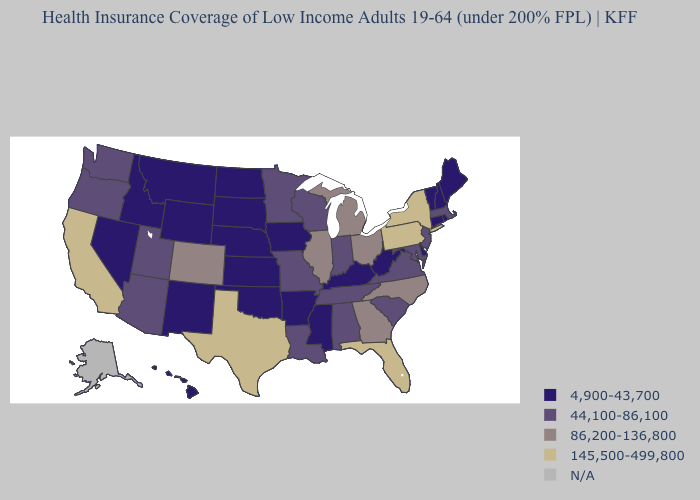What is the value of Minnesota?
Answer briefly. 44,100-86,100. Does Kansas have the highest value in the MidWest?
Keep it brief. No. Name the states that have a value in the range 86,200-136,800?
Answer briefly. Colorado, Georgia, Illinois, Michigan, North Carolina, Ohio. Is the legend a continuous bar?
Be succinct. No. What is the lowest value in the South?
Quick response, please. 4,900-43,700. How many symbols are there in the legend?
Short answer required. 5. Name the states that have a value in the range 86,200-136,800?
Write a very short answer. Colorado, Georgia, Illinois, Michigan, North Carolina, Ohio. Name the states that have a value in the range 4,900-43,700?
Concise answer only. Arkansas, Connecticut, Delaware, Hawaii, Idaho, Iowa, Kansas, Kentucky, Maine, Mississippi, Montana, Nebraska, Nevada, New Hampshire, New Mexico, North Dakota, Oklahoma, Rhode Island, South Dakota, Vermont, West Virginia, Wyoming. What is the value of Maryland?
Concise answer only. 44,100-86,100. What is the value of Wyoming?
Give a very brief answer. 4,900-43,700. Name the states that have a value in the range 145,500-499,800?
Quick response, please. California, Florida, New York, Pennsylvania, Texas. Which states have the highest value in the USA?
Quick response, please. California, Florida, New York, Pennsylvania, Texas. Name the states that have a value in the range 4,900-43,700?
Give a very brief answer. Arkansas, Connecticut, Delaware, Hawaii, Idaho, Iowa, Kansas, Kentucky, Maine, Mississippi, Montana, Nebraska, Nevada, New Hampshire, New Mexico, North Dakota, Oklahoma, Rhode Island, South Dakota, Vermont, West Virginia, Wyoming. Which states hav the highest value in the West?
Write a very short answer. California. 